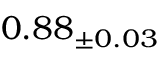<formula> <loc_0><loc_0><loc_500><loc_500>0 . 8 8 _ { \pm 0 . 0 3 }</formula> 